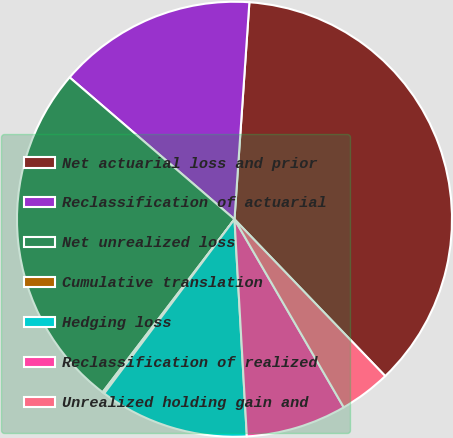<chart> <loc_0><loc_0><loc_500><loc_500><pie_chart><fcel>Net actuarial loss and prior<fcel>Reclassification of actuarial<fcel>Net unrealized loss<fcel>Cumulative translation<fcel>Hedging loss<fcel>Reclassification of realized<fcel>Unrealized holding gain and<nl><fcel>36.72%<fcel>14.78%<fcel>25.94%<fcel>0.15%<fcel>11.12%<fcel>7.47%<fcel>3.81%<nl></chart> 